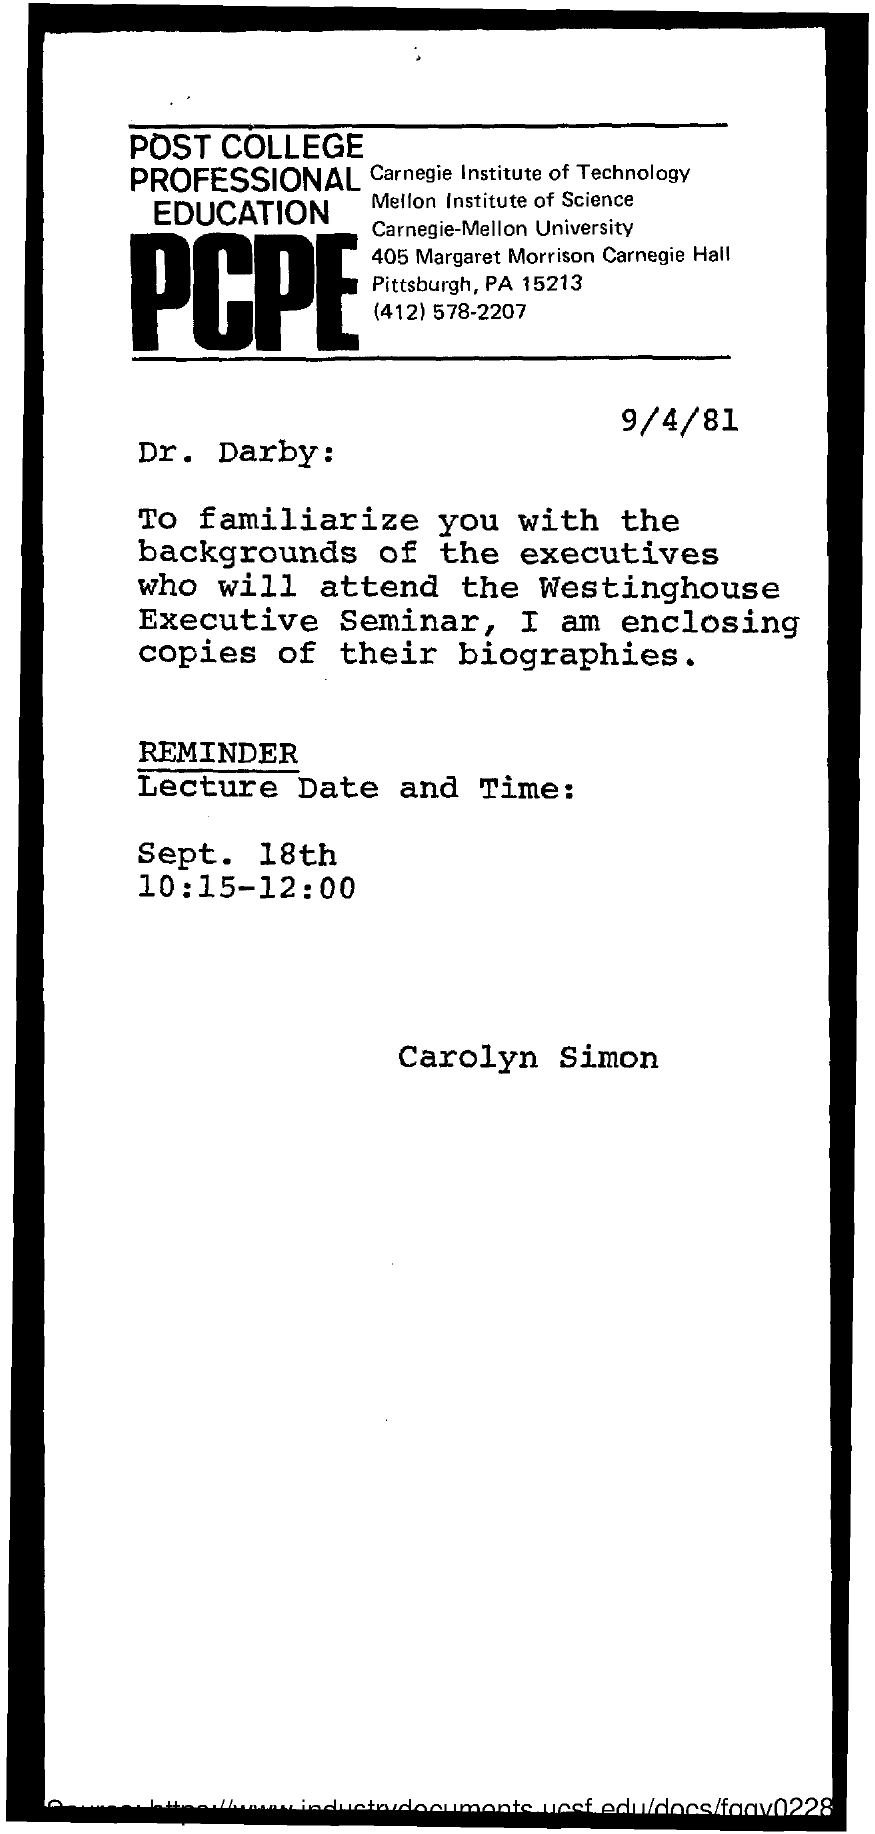List a handful of essential elements in this visual. This letter was written on September 4th, 1981. 